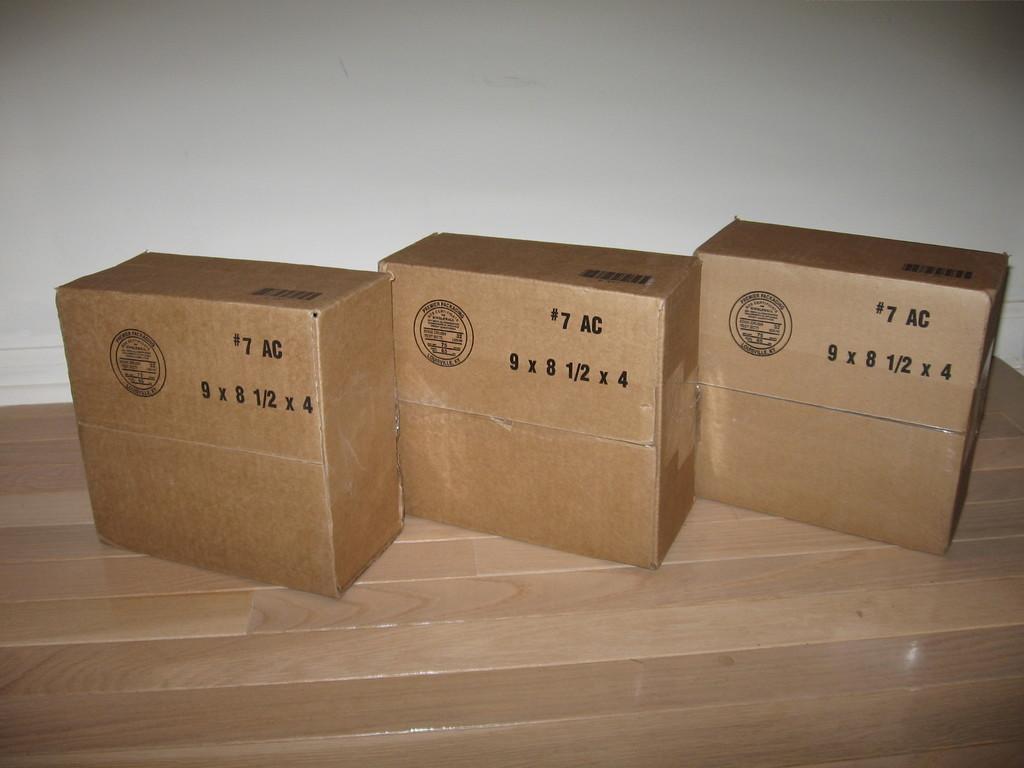What is the top number on all the boxes?
Your answer should be very brief. 7. 